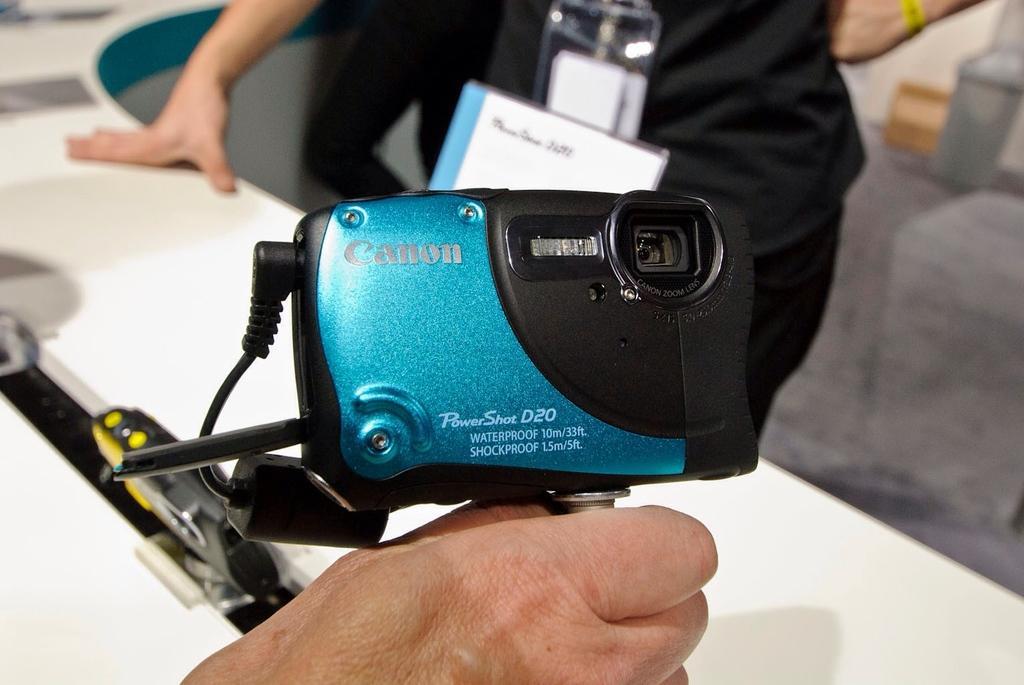Please provide a concise description of this image. In the center of the image we can see a person holding camera. In the background of the image we can see table, two persons, id cards, floor. 